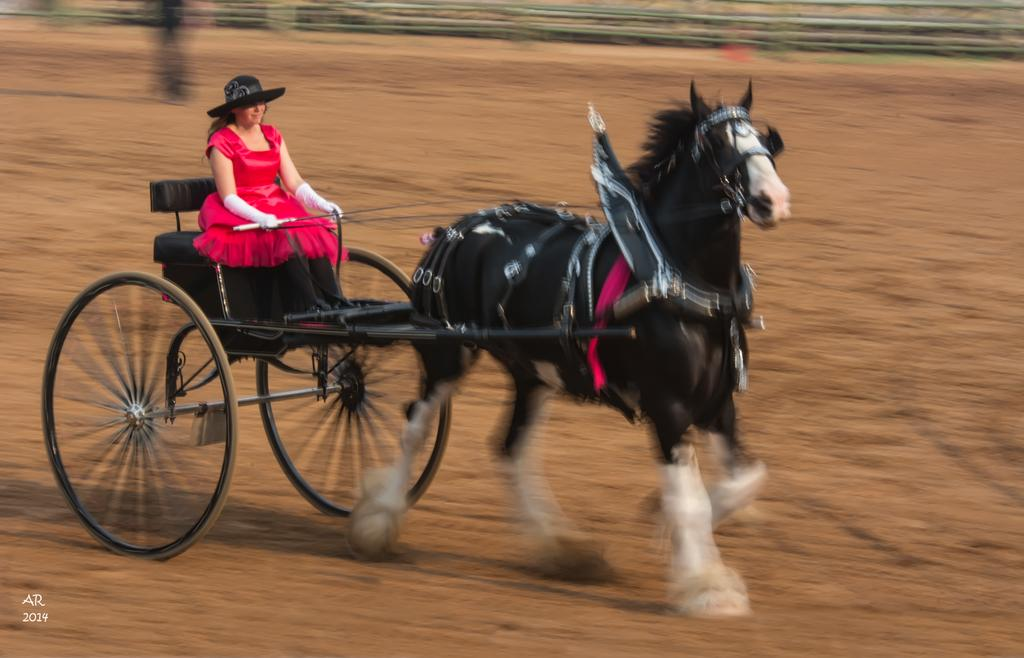Who is the main subject in the image? There is a woman in the image. What is the woman doing in the image? The woman is riding a chariot. What type of bit is used to control the chariot in the image? There is no mention of a bit or any specific control mechanism for the chariot in the image. 